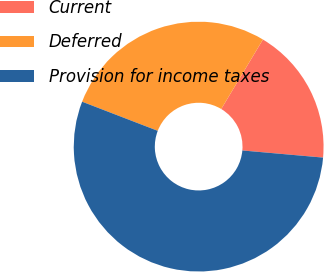Convert chart to OTSL. <chart><loc_0><loc_0><loc_500><loc_500><pie_chart><fcel>Current<fcel>Deferred<fcel>Provision for income taxes<nl><fcel>17.8%<fcel>27.75%<fcel>54.45%<nl></chart> 